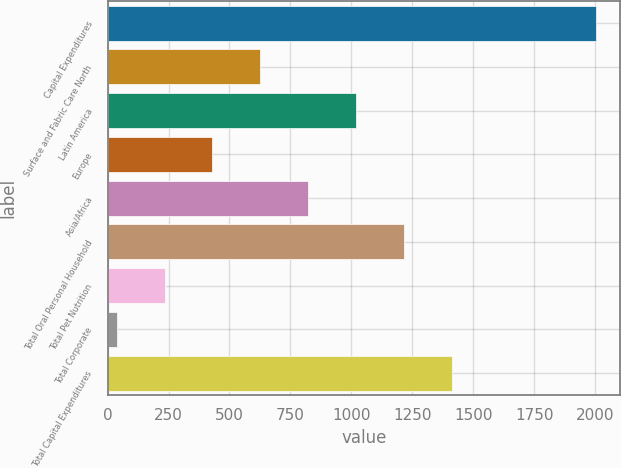Convert chart to OTSL. <chart><loc_0><loc_0><loc_500><loc_500><bar_chart><fcel>Capital Expenditures<fcel>Surface and Fabric Care North<fcel>Latin America<fcel>Europe<fcel>Asia/Africa<fcel>Total Oral Personal Household<fcel>Total Pet Nutrition<fcel>Total Corporate<fcel>Total Capital Expenditures<nl><fcel>2003<fcel>626.87<fcel>1020.05<fcel>430.28<fcel>823.46<fcel>1216.64<fcel>233.69<fcel>37.1<fcel>1413.23<nl></chart> 